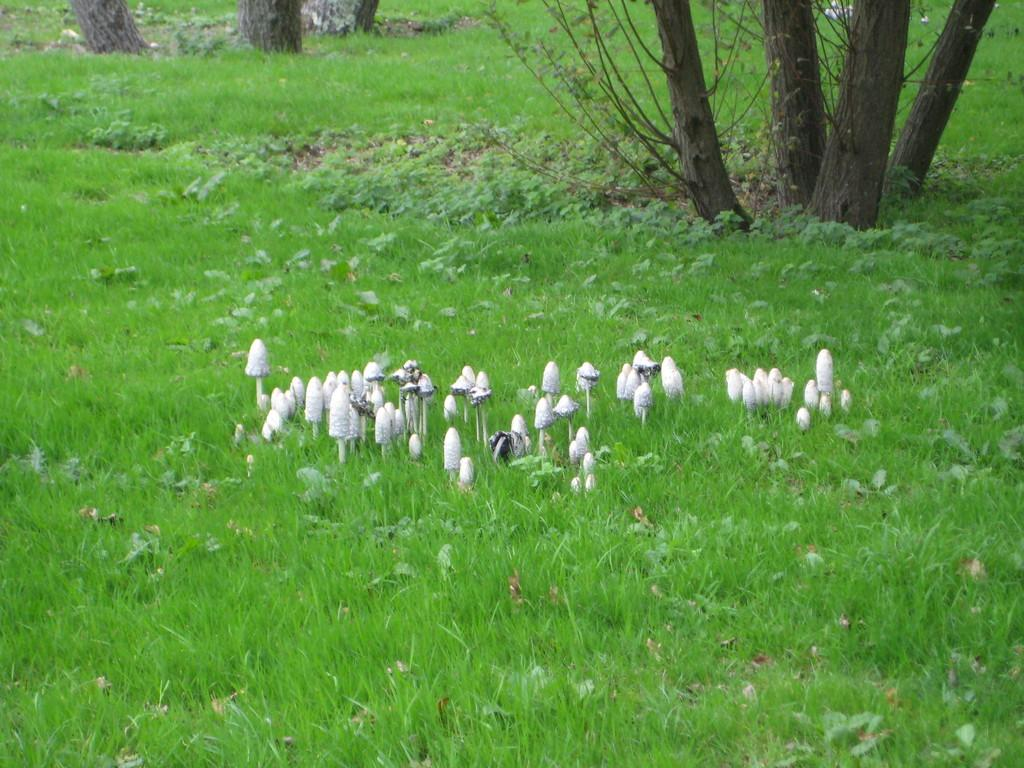What type of vegetation is present in the image? There is green grass in the image. What can be found growing in the grass? There are white mushrooms in the grass. What is visible in the background of the image? There are trees visible behind the mushrooms. What type of wool is being used to create the canvas in the image? There is no canvas or wool present in the image. 